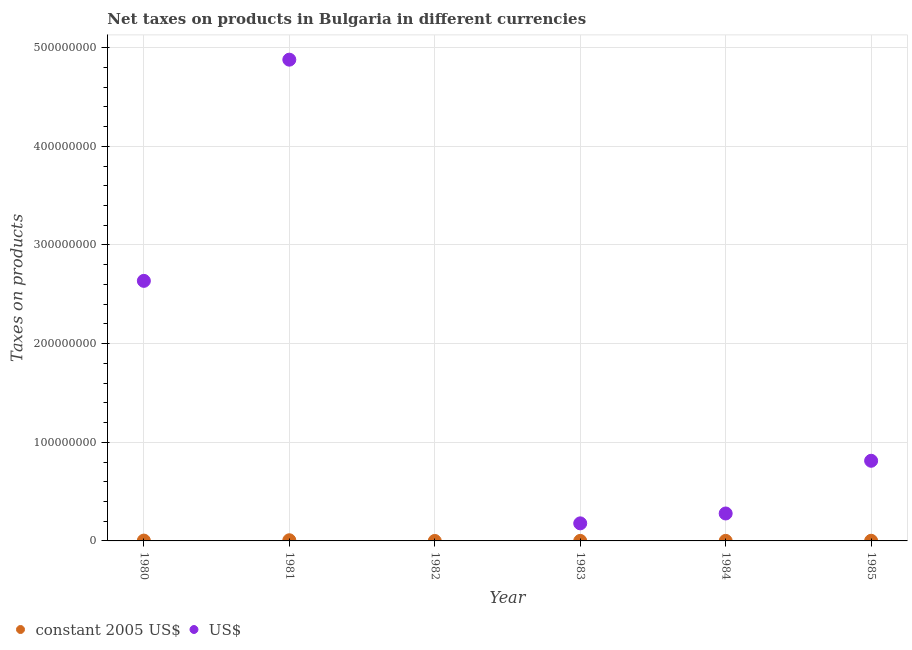Is the number of dotlines equal to the number of legend labels?
Your answer should be very brief. No. What is the net taxes in us$ in 1981?
Give a very brief answer. 4.88e+08. Across all years, what is the maximum net taxes in constant 2005 us$?
Offer a terse response. 6.77e+05. In which year was the net taxes in constant 2005 us$ maximum?
Ensure brevity in your answer.  1981. What is the total net taxes in constant 2005 us$ in the graph?
Offer a very short reply. 1.25e+06. What is the difference between the net taxes in us$ in 1983 and that in 1985?
Keep it short and to the point. -6.34e+07. What is the difference between the net taxes in us$ in 1980 and the net taxes in constant 2005 us$ in 1984?
Provide a short and direct response. 2.64e+08. What is the average net taxes in us$ per year?
Your answer should be very brief. 1.46e+08. In the year 1983, what is the difference between the net taxes in us$ and net taxes in constant 2005 us$?
Provide a succinct answer. 1.78e+07. What is the ratio of the net taxes in constant 2005 us$ in 1980 to that in 1983?
Your response must be concise. 10.84. Is the net taxes in us$ in 1981 less than that in 1985?
Offer a terse response. No. Is the difference between the net taxes in constant 2005 us$ in 1984 and 1985 greater than the difference between the net taxes in us$ in 1984 and 1985?
Make the answer very short. Yes. What is the difference between the highest and the second highest net taxes in constant 2005 us$?
Your answer should be very brief. 3.37e+05. What is the difference between the highest and the lowest net taxes in constant 2005 us$?
Ensure brevity in your answer.  6.77e+05. Is the sum of the net taxes in us$ in 1983 and 1984 greater than the maximum net taxes in constant 2005 us$ across all years?
Your response must be concise. Yes. Is the net taxes in constant 2005 us$ strictly greater than the net taxes in us$ over the years?
Your answer should be very brief. No. How many dotlines are there?
Your answer should be compact. 2. Are the values on the major ticks of Y-axis written in scientific E-notation?
Your answer should be very brief. No. Does the graph contain any zero values?
Provide a short and direct response. Yes. Where does the legend appear in the graph?
Offer a very short reply. Bottom left. How are the legend labels stacked?
Keep it short and to the point. Horizontal. What is the title of the graph?
Make the answer very short. Net taxes on products in Bulgaria in different currencies. What is the label or title of the X-axis?
Offer a terse response. Year. What is the label or title of the Y-axis?
Provide a short and direct response. Taxes on products. What is the Taxes on products in constant 2005 US$ in 1980?
Ensure brevity in your answer.  3.39e+05. What is the Taxes on products in US$ in 1980?
Provide a succinct answer. 2.64e+08. What is the Taxes on products in constant 2005 US$ in 1981?
Your answer should be very brief. 6.77e+05. What is the Taxes on products of US$ in 1981?
Keep it short and to the point. 4.88e+08. What is the Taxes on products in constant 2005 US$ in 1982?
Your answer should be compact. 0. What is the Taxes on products of constant 2005 US$ in 1983?
Your answer should be compact. 3.13e+04. What is the Taxes on products in US$ in 1983?
Ensure brevity in your answer.  1.78e+07. What is the Taxes on products of constant 2005 US$ in 1984?
Offer a very short reply. 5.06e+04. What is the Taxes on products in US$ in 1984?
Provide a succinct answer. 2.78e+07. What is the Taxes on products in constant 2005 US$ in 1985?
Offer a very short reply. 1.51e+05. What is the Taxes on products in US$ in 1985?
Keep it short and to the point. 8.13e+07. Across all years, what is the maximum Taxes on products of constant 2005 US$?
Ensure brevity in your answer.  6.77e+05. Across all years, what is the maximum Taxes on products of US$?
Your answer should be very brief. 4.88e+08. What is the total Taxes on products of constant 2005 US$ in the graph?
Offer a very short reply. 1.25e+06. What is the total Taxes on products of US$ in the graph?
Your response must be concise. 8.78e+08. What is the difference between the Taxes on products of constant 2005 US$ in 1980 and that in 1981?
Provide a succinct answer. -3.37e+05. What is the difference between the Taxes on products in US$ in 1980 and that in 1981?
Your response must be concise. -2.24e+08. What is the difference between the Taxes on products of constant 2005 US$ in 1980 and that in 1983?
Provide a succinct answer. 3.08e+05. What is the difference between the Taxes on products in US$ in 1980 and that in 1983?
Provide a short and direct response. 2.46e+08. What is the difference between the Taxes on products in constant 2005 US$ in 1980 and that in 1984?
Ensure brevity in your answer.  2.89e+05. What is the difference between the Taxes on products of US$ in 1980 and that in 1984?
Give a very brief answer. 2.36e+08. What is the difference between the Taxes on products of constant 2005 US$ in 1980 and that in 1985?
Provide a short and direct response. 1.88e+05. What is the difference between the Taxes on products of US$ in 1980 and that in 1985?
Give a very brief answer. 1.82e+08. What is the difference between the Taxes on products in constant 2005 US$ in 1981 and that in 1983?
Your answer should be very brief. 6.45e+05. What is the difference between the Taxes on products in US$ in 1981 and that in 1983?
Provide a short and direct response. 4.70e+08. What is the difference between the Taxes on products of constant 2005 US$ in 1981 and that in 1984?
Make the answer very short. 6.26e+05. What is the difference between the Taxes on products of US$ in 1981 and that in 1984?
Your answer should be compact. 4.60e+08. What is the difference between the Taxes on products of constant 2005 US$ in 1981 and that in 1985?
Your response must be concise. 5.26e+05. What is the difference between the Taxes on products of US$ in 1981 and that in 1985?
Ensure brevity in your answer.  4.07e+08. What is the difference between the Taxes on products of constant 2005 US$ in 1983 and that in 1984?
Make the answer very short. -1.93e+04. What is the difference between the Taxes on products of US$ in 1983 and that in 1984?
Ensure brevity in your answer.  -1.00e+07. What is the difference between the Taxes on products in constant 2005 US$ in 1983 and that in 1985?
Your response must be concise. -1.20e+05. What is the difference between the Taxes on products of US$ in 1983 and that in 1985?
Offer a terse response. -6.34e+07. What is the difference between the Taxes on products in constant 2005 US$ in 1984 and that in 1985?
Offer a terse response. -1.00e+05. What is the difference between the Taxes on products in US$ in 1984 and that in 1985?
Make the answer very short. -5.34e+07. What is the difference between the Taxes on products in constant 2005 US$ in 1980 and the Taxes on products in US$ in 1981?
Give a very brief answer. -4.88e+08. What is the difference between the Taxes on products in constant 2005 US$ in 1980 and the Taxes on products in US$ in 1983?
Offer a terse response. -1.75e+07. What is the difference between the Taxes on products of constant 2005 US$ in 1980 and the Taxes on products of US$ in 1984?
Your response must be concise. -2.75e+07. What is the difference between the Taxes on products of constant 2005 US$ in 1980 and the Taxes on products of US$ in 1985?
Offer a terse response. -8.09e+07. What is the difference between the Taxes on products of constant 2005 US$ in 1981 and the Taxes on products of US$ in 1983?
Keep it short and to the point. -1.71e+07. What is the difference between the Taxes on products in constant 2005 US$ in 1981 and the Taxes on products in US$ in 1984?
Ensure brevity in your answer.  -2.71e+07. What is the difference between the Taxes on products in constant 2005 US$ in 1981 and the Taxes on products in US$ in 1985?
Your answer should be compact. -8.06e+07. What is the difference between the Taxes on products of constant 2005 US$ in 1983 and the Taxes on products of US$ in 1984?
Keep it short and to the point. -2.78e+07. What is the difference between the Taxes on products in constant 2005 US$ in 1983 and the Taxes on products in US$ in 1985?
Your answer should be compact. -8.12e+07. What is the difference between the Taxes on products of constant 2005 US$ in 1984 and the Taxes on products of US$ in 1985?
Offer a very short reply. -8.12e+07. What is the average Taxes on products in constant 2005 US$ per year?
Provide a succinct answer. 2.08e+05. What is the average Taxes on products of US$ per year?
Your answer should be compact. 1.46e+08. In the year 1980, what is the difference between the Taxes on products in constant 2005 US$ and Taxes on products in US$?
Ensure brevity in your answer.  -2.63e+08. In the year 1981, what is the difference between the Taxes on products in constant 2005 US$ and Taxes on products in US$?
Give a very brief answer. -4.87e+08. In the year 1983, what is the difference between the Taxes on products in constant 2005 US$ and Taxes on products in US$?
Provide a succinct answer. -1.78e+07. In the year 1984, what is the difference between the Taxes on products of constant 2005 US$ and Taxes on products of US$?
Keep it short and to the point. -2.78e+07. In the year 1985, what is the difference between the Taxes on products of constant 2005 US$ and Taxes on products of US$?
Give a very brief answer. -8.11e+07. What is the ratio of the Taxes on products of constant 2005 US$ in 1980 to that in 1981?
Your answer should be compact. 0.5. What is the ratio of the Taxes on products in US$ in 1980 to that in 1981?
Keep it short and to the point. 0.54. What is the ratio of the Taxes on products of constant 2005 US$ in 1980 to that in 1983?
Your response must be concise. 10.84. What is the ratio of the Taxes on products of US$ in 1980 to that in 1983?
Your response must be concise. 14.81. What is the ratio of the Taxes on products in constant 2005 US$ in 1980 to that in 1984?
Your answer should be very brief. 6.71. What is the ratio of the Taxes on products of US$ in 1980 to that in 1984?
Provide a succinct answer. 9.48. What is the ratio of the Taxes on products in constant 2005 US$ in 1980 to that in 1985?
Your response must be concise. 2.25. What is the ratio of the Taxes on products of US$ in 1980 to that in 1985?
Your answer should be very brief. 3.24. What is the ratio of the Taxes on products of constant 2005 US$ in 1981 to that in 1983?
Provide a succinct answer. 21.62. What is the ratio of the Taxes on products of US$ in 1981 to that in 1983?
Offer a very short reply. 27.4. What is the ratio of the Taxes on products of constant 2005 US$ in 1981 to that in 1984?
Your response must be concise. 13.37. What is the ratio of the Taxes on products of US$ in 1981 to that in 1984?
Offer a terse response. 17.54. What is the ratio of the Taxes on products of constant 2005 US$ in 1981 to that in 1985?
Make the answer very short. 4.49. What is the ratio of the Taxes on products of US$ in 1981 to that in 1985?
Your response must be concise. 6. What is the ratio of the Taxes on products in constant 2005 US$ in 1983 to that in 1984?
Ensure brevity in your answer.  0.62. What is the ratio of the Taxes on products of US$ in 1983 to that in 1984?
Make the answer very short. 0.64. What is the ratio of the Taxes on products of constant 2005 US$ in 1983 to that in 1985?
Keep it short and to the point. 0.21. What is the ratio of the Taxes on products in US$ in 1983 to that in 1985?
Ensure brevity in your answer.  0.22. What is the ratio of the Taxes on products of constant 2005 US$ in 1984 to that in 1985?
Give a very brief answer. 0.34. What is the ratio of the Taxes on products in US$ in 1984 to that in 1985?
Ensure brevity in your answer.  0.34. What is the difference between the highest and the second highest Taxes on products in constant 2005 US$?
Offer a very short reply. 3.37e+05. What is the difference between the highest and the second highest Taxes on products in US$?
Your answer should be compact. 2.24e+08. What is the difference between the highest and the lowest Taxes on products of constant 2005 US$?
Offer a very short reply. 6.77e+05. What is the difference between the highest and the lowest Taxes on products in US$?
Keep it short and to the point. 4.88e+08. 